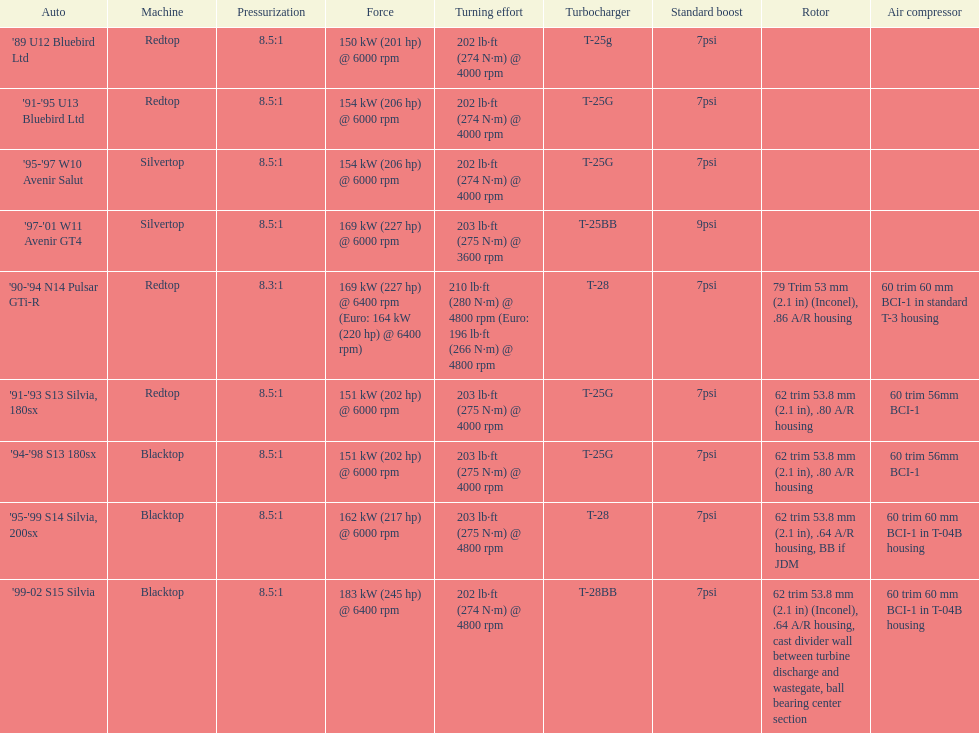After 1999, which engines were employed? Silvertop, Blacktop. 